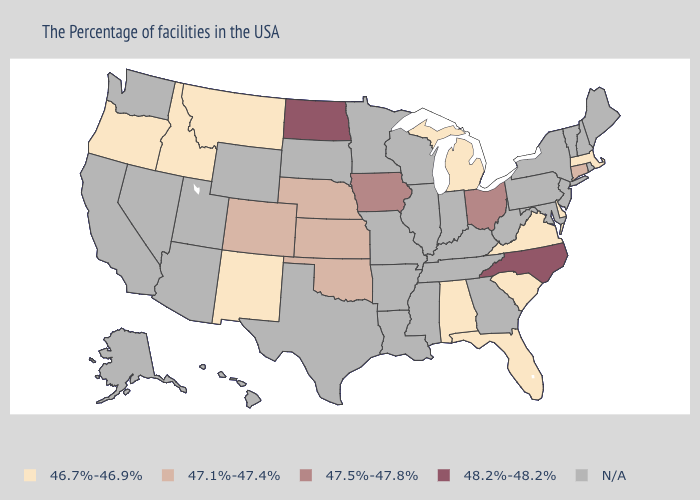What is the value of Louisiana?
Write a very short answer. N/A. Name the states that have a value in the range N/A?
Keep it brief. Maine, Rhode Island, New Hampshire, Vermont, New York, New Jersey, Maryland, Pennsylvania, West Virginia, Georgia, Kentucky, Indiana, Tennessee, Wisconsin, Illinois, Mississippi, Louisiana, Missouri, Arkansas, Minnesota, Texas, South Dakota, Wyoming, Utah, Arizona, Nevada, California, Washington, Alaska, Hawaii. Name the states that have a value in the range 48.2%-48.2%?
Write a very short answer. North Carolina, North Dakota. What is the value of Wisconsin?
Be succinct. N/A. Is the legend a continuous bar?
Answer briefly. No. Among the states that border Nebraska , does Iowa have the highest value?
Short answer required. Yes. Name the states that have a value in the range 48.2%-48.2%?
Answer briefly. North Carolina, North Dakota. Which states have the lowest value in the West?
Quick response, please. New Mexico, Montana, Idaho, Oregon. Does North Dakota have the highest value in the USA?
Write a very short answer. Yes. What is the value of Tennessee?
Quick response, please. N/A. Among the states that border South Dakota , does Montana have the lowest value?
Keep it brief. Yes. Name the states that have a value in the range 47.1%-47.4%?
Be succinct. Connecticut, Kansas, Nebraska, Oklahoma, Colorado. Does the map have missing data?
Concise answer only. Yes. What is the value of Minnesota?
Answer briefly. N/A. 